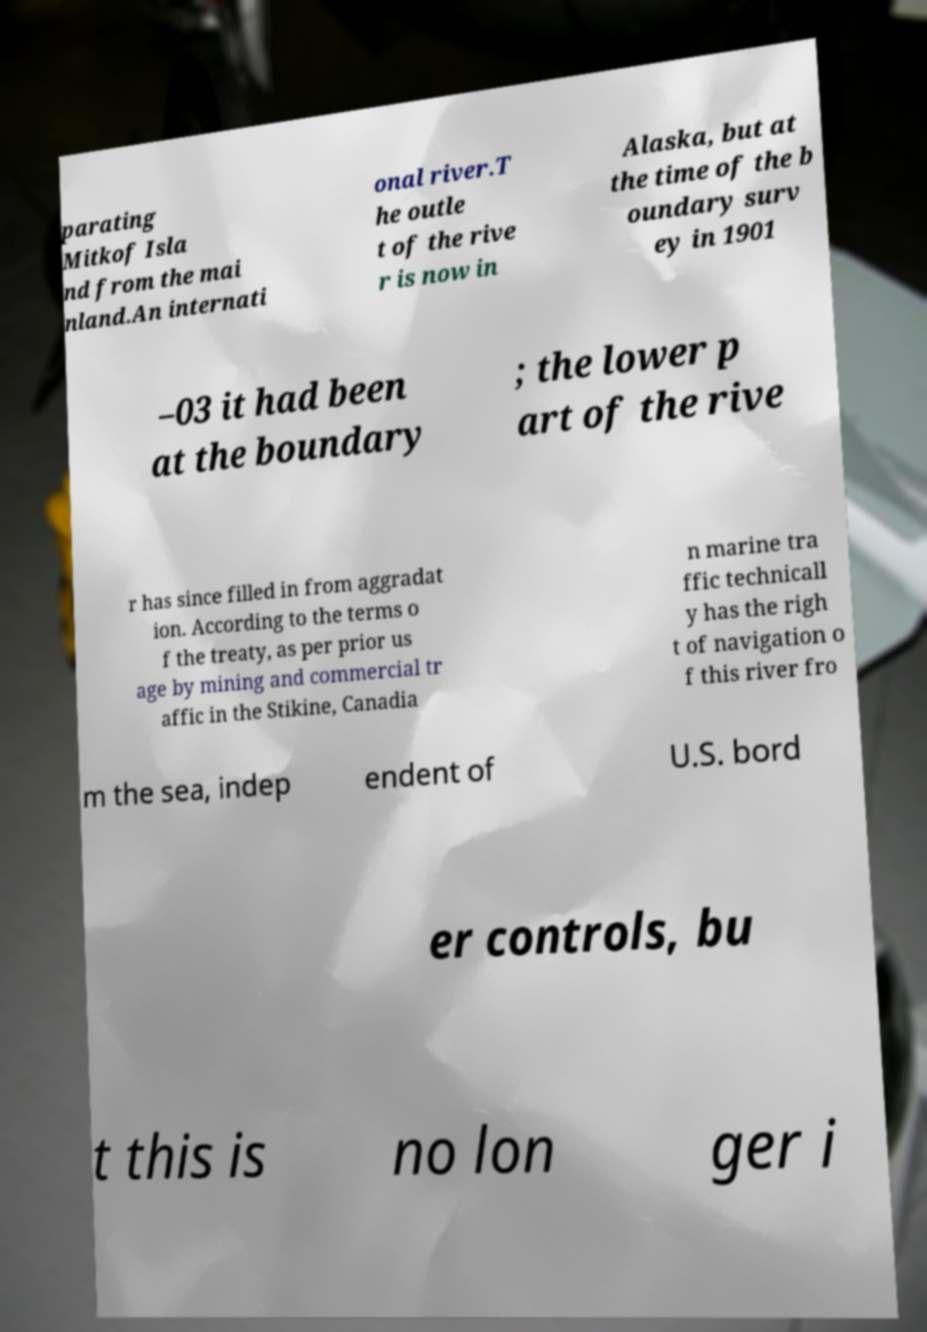Can you read and provide the text displayed in the image?This photo seems to have some interesting text. Can you extract and type it out for me? parating Mitkof Isla nd from the mai nland.An internati onal river.T he outle t of the rive r is now in Alaska, but at the time of the b oundary surv ey in 1901 –03 it had been at the boundary ; the lower p art of the rive r has since filled in from aggradat ion. According to the terms o f the treaty, as per prior us age by mining and commercial tr affic in the Stikine, Canadia n marine tra ffic technicall y has the righ t of navigation o f this river fro m the sea, indep endent of U.S. bord er controls, bu t this is no lon ger i 